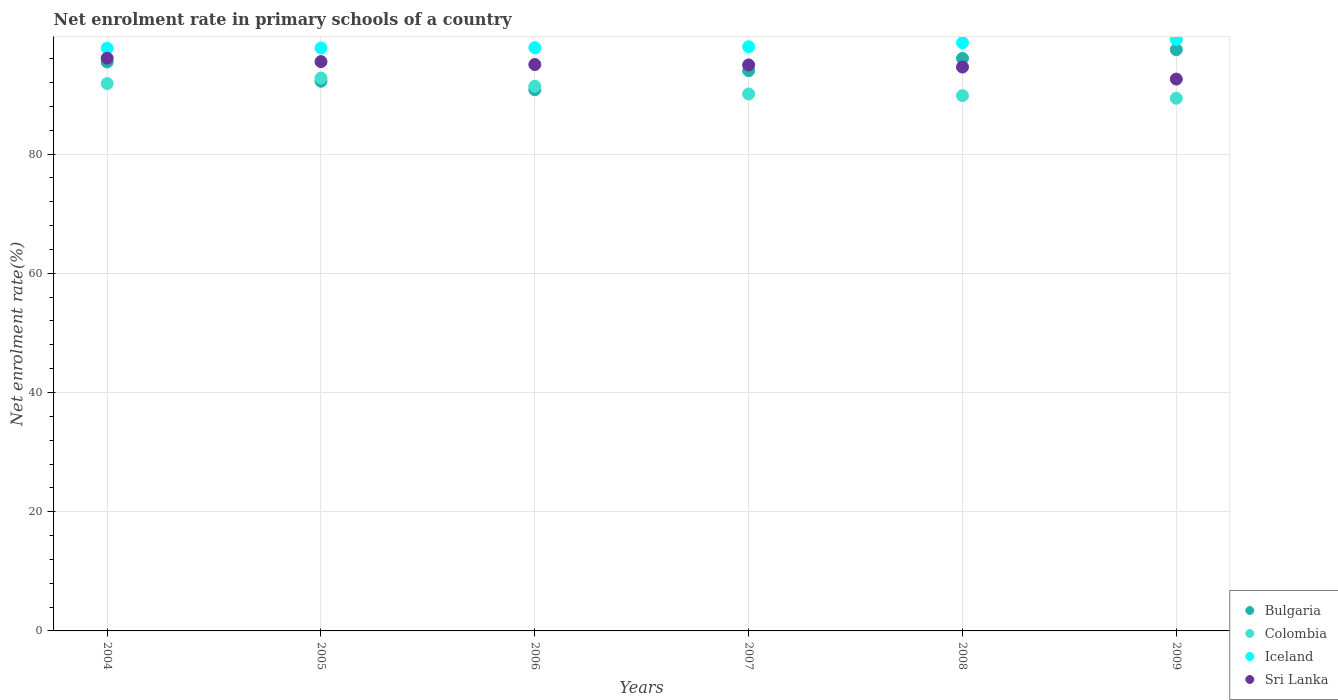How many different coloured dotlines are there?
Provide a short and direct response. 4. What is the net enrolment rate in primary schools in Iceland in 2005?
Give a very brief answer. 97.81. Across all years, what is the maximum net enrolment rate in primary schools in Colombia?
Keep it short and to the point. 92.77. Across all years, what is the minimum net enrolment rate in primary schools in Colombia?
Provide a succinct answer. 89.37. In which year was the net enrolment rate in primary schools in Sri Lanka maximum?
Give a very brief answer. 2004. What is the total net enrolment rate in primary schools in Bulgaria in the graph?
Your response must be concise. 566.08. What is the difference between the net enrolment rate in primary schools in Colombia in 2004 and that in 2007?
Your answer should be very brief. 1.74. What is the difference between the net enrolment rate in primary schools in Colombia in 2004 and the net enrolment rate in primary schools in Bulgaria in 2009?
Your answer should be very brief. -5.69. What is the average net enrolment rate in primary schools in Bulgaria per year?
Make the answer very short. 94.35. In the year 2009, what is the difference between the net enrolment rate in primary schools in Bulgaria and net enrolment rate in primary schools in Iceland?
Offer a terse response. -1.7. What is the ratio of the net enrolment rate in primary schools in Colombia in 2008 to that in 2009?
Your answer should be very brief. 1. Is the difference between the net enrolment rate in primary schools in Bulgaria in 2004 and 2009 greater than the difference between the net enrolment rate in primary schools in Iceland in 2004 and 2009?
Your answer should be compact. No. What is the difference between the highest and the second highest net enrolment rate in primary schools in Sri Lanka?
Ensure brevity in your answer.  0.57. What is the difference between the highest and the lowest net enrolment rate in primary schools in Iceland?
Ensure brevity in your answer.  1.47. Is it the case that in every year, the sum of the net enrolment rate in primary schools in Sri Lanka and net enrolment rate in primary schools in Bulgaria  is greater than the net enrolment rate in primary schools in Iceland?
Offer a terse response. Yes. Is the net enrolment rate in primary schools in Sri Lanka strictly less than the net enrolment rate in primary schools in Bulgaria over the years?
Offer a very short reply. No. How many dotlines are there?
Make the answer very short. 4. What is the difference between two consecutive major ticks on the Y-axis?
Your answer should be compact. 20. Are the values on the major ticks of Y-axis written in scientific E-notation?
Provide a succinct answer. No. Does the graph contain any zero values?
Offer a very short reply. No. Does the graph contain grids?
Provide a short and direct response. Yes. Where does the legend appear in the graph?
Provide a succinct answer. Bottom right. How many legend labels are there?
Your answer should be very brief. 4. What is the title of the graph?
Keep it short and to the point. Net enrolment rate in primary schools of a country. What is the label or title of the X-axis?
Your response must be concise. Years. What is the label or title of the Y-axis?
Give a very brief answer. Net enrolment rate(%). What is the Net enrolment rate(%) in Bulgaria in 2004?
Offer a terse response. 95.46. What is the Net enrolment rate(%) in Colombia in 2004?
Make the answer very short. 91.84. What is the Net enrolment rate(%) of Iceland in 2004?
Offer a terse response. 97.75. What is the Net enrolment rate(%) in Sri Lanka in 2004?
Your answer should be compact. 96.09. What is the Net enrolment rate(%) of Bulgaria in 2005?
Offer a terse response. 92.23. What is the Net enrolment rate(%) of Colombia in 2005?
Offer a very short reply. 92.77. What is the Net enrolment rate(%) of Iceland in 2005?
Provide a short and direct response. 97.81. What is the Net enrolment rate(%) of Sri Lanka in 2005?
Provide a short and direct response. 95.52. What is the Net enrolment rate(%) of Bulgaria in 2006?
Your answer should be very brief. 90.8. What is the Net enrolment rate(%) of Colombia in 2006?
Keep it short and to the point. 91.39. What is the Net enrolment rate(%) of Iceland in 2006?
Make the answer very short. 97.86. What is the Net enrolment rate(%) of Sri Lanka in 2006?
Ensure brevity in your answer.  95.03. What is the Net enrolment rate(%) of Bulgaria in 2007?
Make the answer very short. 94. What is the Net enrolment rate(%) of Colombia in 2007?
Give a very brief answer. 90.09. What is the Net enrolment rate(%) in Iceland in 2007?
Provide a short and direct response. 98.01. What is the Net enrolment rate(%) of Sri Lanka in 2007?
Your answer should be very brief. 94.96. What is the Net enrolment rate(%) in Bulgaria in 2008?
Give a very brief answer. 96.05. What is the Net enrolment rate(%) in Colombia in 2008?
Your response must be concise. 89.81. What is the Net enrolment rate(%) of Iceland in 2008?
Your answer should be very brief. 98.69. What is the Net enrolment rate(%) in Sri Lanka in 2008?
Offer a terse response. 94.61. What is the Net enrolment rate(%) of Bulgaria in 2009?
Give a very brief answer. 97.53. What is the Net enrolment rate(%) of Colombia in 2009?
Provide a short and direct response. 89.37. What is the Net enrolment rate(%) of Iceland in 2009?
Your response must be concise. 99.23. What is the Net enrolment rate(%) in Sri Lanka in 2009?
Provide a short and direct response. 92.59. Across all years, what is the maximum Net enrolment rate(%) in Bulgaria?
Keep it short and to the point. 97.53. Across all years, what is the maximum Net enrolment rate(%) in Colombia?
Ensure brevity in your answer.  92.77. Across all years, what is the maximum Net enrolment rate(%) in Iceland?
Your response must be concise. 99.23. Across all years, what is the maximum Net enrolment rate(%) of Sri Lanka?
Offer a very short reply. 96.09. Across all years, what is the minimum Net enrolment rate(%) of Bulgaria?
Provide a succinct answer. 90.8. Across all years, what is the minimum Net enrolment rate(%) of Colombia?
Make the answer very short. 89.37. Across all years, what is the minimum Net enrolment rate(%) of Iceland?
Ensure brevity in your answer.  97.75. Across all years, what is the minimum Net enrolment rate(%) in Sri Lanka?
Your response must be concise. 92.59. What is the total Net enrolment rate(%) in Bulgaria in the graph?
Provide a short and direct response. 566.08. What is the total Net enrolment rate(%) of Colombia in the graph?
Offer a very short reply. 545.26. What is the total Net enrolment rate(%) of Iceland in the graph?
Provide a short and direct response. 589.35. What is the total Net enrolment rate(%) in Sri Lanka in the graph?
Make the answer very short. 568.8. What is the difference between the Net enrolment rate(%) of Bulgaria in 2004 and that in 2005?
Offer a terse response. 3.23. What is the difference between the Net enrolment rate(%) in Colombia in 2004 and that in 2005?
Your response must be concise. -0.93. What is the difference between the Net enrolment rate(%) of Iceland in 2004 and that in 2005?
Make the answer very short. -0.05. What is the difference between the Net enrolment rate(%) in Sri Lanka in 2004 and that in 2005?
Your response must be concise. 0.57. What is the difference between the Net enrolment rate(%) in Bulgaria in 2004 and that in 2006?
Your answer should be very brief. 4.66. What is the difference between the Net enrolment rate(%) in Colombia in 2004 and that in 2006?
Your answer should be compact. 0.45. What is the difference between the Net enrolment rate(%) of Iceland in 2004 and that in 2006?
Keep it short and to the point. -0.1. What is the difference between the Net enrolment rate(%) in Sri Lanka in 2004 and that in 2006?
Keep it short and to the point. 1.06. What is the difference between the Net enrolment rate(%) in Bulgaria in 2004 and that in 2007?
Offer a very short reply. 1.47. What is the difference between the Net enrolment rate(%) in Colombia in 2004 and that in 2007?
Provide a short and direct response. 1.74. What is the difference between the Net enrolment rate(%) in Iceland in 2004 and that in 2007?
Give a very brief answer. -0.25. What is the difference between the Net enrolment rate(%) in Sri Lanka in 2004 and that in 2007?
Your response must be concise. 1.13. What is the difference between the Net enrolment rate(%) in Bulgaria in 2004 and that in 2008?
Offer a very short reply. -0.59. What is the difference between the Net enrolment rate(%) of Colombia in 2004 and that in 2008?
Make the answer very short. 2.03. What is the difference between the Net enrolment rate(%) of Iceland in 2004 and that in 2008?
Offer a very short reply. -0.94. What is the difference between the Net enrolment rate(%) in Sri Lanka in 2004 and that in 2008?
Keep it short and to the point. 1.48. What is the difference between the Net enrolment rate(%) in Bulgaria in 2004 and that in 2009?
Offer a terse response. -2.06. What is the difference between the Net enrolment rate(%) of Colombia in 2004 and that in 2009?
Provide a short and direct response. 2.47. What is the difference between the Net enrolment rate(%) of Iceland in 2004 and that in 2009?
Provide a succinct answer. -1.47. What is the difference between the Net enrolment rate(%) of Sri Lanka in 2004 and that in 2009?
Offer a very short reply. 3.5. What is the difference between the Net enrolment rate(%) in Bulgaria in 2005 and that in 2006?
Your response must be concise. 1.43. What is the difference between the Net enrolment rate(%) of Colombia in 2005 and that in 2006?
Provide a succinct answer. 1.38. What is the difference between the Net enrolment rate(%) in Iceland in 2005 and that in 2006?
Provide a short and direct response. -0.05. What is the difference between the Net enrolment rate(%) of Sri Lanka in 2005 and that in 2006?
Your answer should be very brief. 0.49. What is the difference between the Net enrolment rate(%) in Bulgaria in 2005 and that in 2007?
Your answer should be compact. -1.77. What is the difference between the Net enrolment rate(%) of Colombia in 2005 and that in 2007?
Ensure brevity in your answer.  2.67. What is the difference between the Net enrolment rate(%) in Iceland in 2005 and that in 2007?
Offer a very short reply. -0.2. What is the difference between the Net enrolment rate(%) of Sri Lanka in 2005 and that in 2007?
Your response must be concise. 0.56. What is the difference between the Net enrolment rate(%) of Bulgaria in 2005 and that in 2008?
Your answer should be very brief. -3.83. What is the difference between the Net enrolment rate(%) in Colombia in 2005 and that in 2008?
Make the answer very short. 2.96. What is the difference between the Net enrolment rate(%) in Iceland in 2005 and that in 2008?
Offer a terse response. -0.89. What is the difference between the Net enrolment rate(%) of Sri Lanka in 2005 and that in 2008?
Provide a short and direct response. 0.91. What is the difference between the Net enrolment rate(%) in Bulgaria in 2005 and that in 2009?
Your answer should be very brief. -5.3. What is the difference between the Net enrolment rate(%) of Colombia in 2005 and that in 2009?
Give a very brief answer. 3.4. What is the difference between the Net enrolment rate(%) in Iceland in 2005 and that in 2009?
Your response must be concise. -1.42. What is the difference between the Net enrolment rate(%) in Sri Lanka in 2005 and that in 2009?
Offer a terse response. 2.93. What is the difference between the Net enrolment rate(%) of Bulgaria in 2006 and that in 2007?
Give a very brief answer. -3.19. What is the difference between the Net enrolment rate(%) of Colombia in 2006 and that in 2007?
Give a very brief answer. 1.29. What is the difference between the Net enrolment rate(%) in Iceland in 2006 and that in 2007?
Give a very brief answer. -0.15. What is the difference between the Net enrolment rate(%) of Sri Lanka in 2006 and that in 2007?
Give a very brief answer. 0.07. What is the difference between the Net enrolment rate(%) in Bulgaria in 2006 and that in 2008?
Your answer should be very brief. -5.25. What is the difference between the Net enrolment rate(%) of Colombia in 2006 and that in 2008?
Your answer should be very brief. 1.58. What is the difference between the Net enrolment rate(%) of Iceland in 2006 and that in 2008?
Your answer should be very brief. -0.84. What is the difference between the Net enrolment rate(%) of Sri Lanka in 2006 and that in 2008?
Make the answer very short. 0.42. What is the difference between the Net enrolment rate(%) in Bulgaria in 2006 and that in 2009?
Offer a very short reply. -6.72. What is the difference between the Net enrolment rate(%) of Colombia in 2006 and that in 2009?
Offer a terse response. 2.02. What is the difference between the Net enrolment rate(%) in Iceland in 2006 and that in 2009?
Give a very brief answer. -1.37. What is the difference between the Net enrolment rate(%) in Sri Lanka in 2006 and that in 2009?
Ensure brevity in your answer.  2.44. What is the difference between the Net enrolment rate(%) of Bulgaria in 2007 and that in 2008?
Ensure brevity in your answer.  -2.06. What is the difference between the Net enrolment rate(%) in Colombia in 2007 and that in 2008?
Offer a very short reply. 0.29. What is the difference between the Net enrolment rate(%) in Iceland in 2007 and that in 2008?
Offer a very short reply. -0.69. What is the difference between the Net enrolment rate(%) of Sri Lanka in 2007 and that in 2008?
Offer a very short reply. 0.35. What is the difference between the Net enrolment rate(%) in Bulgaria in 2007 and that in 2009?
Give a very brief answer. -3.53. What is the difference between the Net enrolment rate(%) in Colombia in 2007 and that in 2009?
Make the answer very short. 0.73. What is the difference between the Net enrolment rate(%) of Iceland in 2007 and that in 2009?
Ensure brevity in your answer.  -1.22. What is the difference between the Net enrolment rate(%) of Sri Lanka in 2007 and that in 2009?
Provide a short and direct response. 2.37. What is the difference between the Net enrolment rate(%) in Bulgaria in 2008 and that in 2009?
Your answer should be very brief. -1.47. What is the difference between the Net enrolment rate(%) in Colombia in 2008 and that in 2009?
Offer a very short reply. 0.44. What is the difference between the Net enrolment rate(%) in Iceland in 2008 and that in 2009?
Provide a short and direct response. -0.53. What is the difference between the Net enrolment rate(%) of Sri Lanka in 2008 and that in 2009?
Make the answer very short. 2.02. What is the difference between the Net enrolment rate(%) of Bulgaria in 2004 and the Net enrolment rate(%) of Colombia in 2005?
Keep it short and to the point. 2.7. What is the difference between the Net enrolment rate(%) of Bulgaria in 2004 and the Net enrolment rate(%) of Iceland in 2005?
Your response must be concise. -2.35. What is the difference between the Net enrolment rate(%) of Bulgaria in 2004 and the Net enrolment rate(%) of Sri Lanka in 2005?
Your answer should be compact. -0.06. What is the difference between the Net enrolment rate(%) of Colombia in 2004 and the Net enrolment rate(%) of Iceland in 2005?
Provide a short and direct response. -5.97. What is the difference between the Net enrolment rate(%) of Colombia in 2004 and the Net enrolment rate(%) of Sri Lanka in 2005?
Your answer should be compact. -3.68. What is the difference between the Net enrolment rate(%) in Iceland in 2004 and the Net enrolment rate(%) in Sri Lanka in 2005?
Your answer should be compact. 2.23. What is the difference between the Net enrolment rate(%) of Bulgaria in 2004 and the Net enrolment rate(%) of Colombia in 2006?
Your answer should be compact. 4.08. What is the difference between the Net enrolment rate(%) of Bulgaria in 2004 and the Net enrolment rate(%) of Iceland in 2006?
Offer a very short reply. -2.39. What is the difference between the Net enrolment rate(%) in Bulgaria in 2004 and the Net enrolment rate(%) in Sri Lanka in 2006?
Your answer should be compact. 0.43. What is the difference between the Net enrolment rate(%) in Colombia in 2004 and the Net enrolment rate(%) in Iceland in 2006?
Provide a succinct answer. -6.02. What is the difference between the Net enrolment rate(%) of Colombia in 2004 and the Net enrolment rate(%) of Sri Lanka in 2006?
Give a very brief answer. -3.19. What is the difference between the Net enrolment rate(%) in Iceland in 2004 and the Net enrolment rate(%) in Sri Lanka in 2006?
Provide a succinct answer. 2.72. What is the difference between the Net enrolment rate(%) in Bulgaria in 2004 and the Net enrolment rate(%) in Colombia in 2007?
Give a very brief answer. 5.37. What is the difference between the Net enrolment rate(%) in Bulgaria in 2004 and the Net enrolment rate(%) in Iceland in 2007?
Your response must be concise. -2.54. What is the difference between the Net enrolment rate(%) in Bulgaria in 2004 and the Net enrolment rate(%) in Sri Lanka in 2007?
Make the answer very short. 0.5. What is the difference between the Net enrolment rate(%) of Colombia in 2004 and the Net enrolment rate(%) of Iceland in 2007?
Your response must be concise. -6.17. What is the difference between the Net enrolment rate(%) of Colombia in 2004 and the Net enrolment rate(%) of Sri Lanka in 2007?
Give a very brief answer. -3.12. What is the difference between the Net enrolment rate(%) of Iceland in 2004 and the Net enrolment rate(%) of Sri Lanka in 2007?
Offer a terse response. 2.79. What is the difference between the Net enrolment rate(%) of Bulgaria in 2004 and the Net enrolment rate(%) of Colombia in 2008?
Ensure brevity in your answer.  5.65. What is the difference between the Net enrolment rate(%) in Bulgaria in 2004 and the Net enrolment rate(%) in Iceland in 2008?
Offer a terse response. -3.23. What is the difference between the Net enrolment rate(%) of Bulgaria in 2004 and the Net enrolment rate(%) of Sri Lanka in 2008?
Keep it short and to the point. 0.85. What is the difference between the Net enrolment rate(%) of Colombia in 2004 and the Net enrolment rate(%) of Iceland in 2008?
Your response must be concise. -6.85. What is the difference between the Net enrolment rate(%) in Colombia in 2004 and the Net enrolment rate(%) in Sri Lanka in 2008?
Your answer should be compact. -2.77. What is the difference between the Net enrolment rate(%) in Iceland in 2004 and the Net enrolment rate(%) in Sri Lanka in 2008?
Offer a terse response. 3.15. What is the difference between the Net enrolment rate(%) in Bulgaria in 2004 and the Net enrolment rate(%) in Colombia in 2009?
Provide a short and direct response. 6.09. What is the difference between the Net enrolment rate(%) in Bulgaria in 2004 and the Net enrolment rate(%) in Iceland in 2009?
Provide a short and direct response. -3.76. What is the difference between the Net enrolment rate(%) in Bulgaria in 2004 and the Net enrolment rate(%) in Sri Lanka in 2009?
Keep it short and to the point. 2.87. What is the difference between the Net enrolment rate(%) in Colombia in 2004 and the Net enrolment rate(%) in Iceland in 2009?
Provide a succinct answer. -7.39. What is the difference between the Net enrolment rate(%) in Colombia in 2004 and the Net enrolment rate(%) in Sri Lanka in 2009?
Your answer should be compact. -0.75. What is the difference between the Net enrolment rate(%) of Iceland in 2004 and the Net enrolment rate(%) of Sri Lanka in 2009?
Offer a terse response. 5.16. What is the difference between the Net enrolment rate(%) of Bulgaria in 2005 and the Net enrolment rate(%) of Colombia in 2006?
Provide a short and direct response. 0.84. What is the difference between the Net enrolment rate(%) in Bulgaria in 2005 and the Net enrolment rate(%) in Iceland in 2006?
Give a very brief answer. -5.63. What is the difference between the Net enrolment rate(%) of Bulgaria in 2005 and the Net enrolment rate(%) of Sri Lanka in 2006?
Provide a succinct answer. -2.8. What is the difference between the Net enrolment rate(%) of Colombia in 2005 and the Net enrolment rate(%) of Iceland in 2006?
Give a very brief answer. -5.09. What is the difference between the Net enrolment rate(%) in Colombia in 2005 and the Net enrolment rate(%) in Sri Lanka in 2006?
Provide a succinct answer. -2.26. What is the difference between the Net enrolment rate(%) of Iceland in 2005 and the Net enrolment rate(%) of Sri Lanka in 2006?
Ensure brevity in your answer.  2.78. What is the difference between the Net enrolment rate(%) of Bulgaria in 2005 and the Net enrolment rate(%) of Colombia in 2007?
Ensure brevity in your answer.  2.13. What is the difference between the Net enrolment rate(%) in Bulgaria in 2005 and the Net enrolment rate(%) in Iceland in 2007?
Your answer should be compact. -5.78. What is the difference between the Net enrolment rate(%) in Bulgaria in 2005 and the Net enrolment rate(%) in Sri Lanka in 2007?
Keep it short and to the point. -2.73. What is the difference between the Net enrolment rate(%) in Colombia in 2005 and the Net enrolment rate(%) in Iceland in 2007?
Your response must be concise. -5.24. What is the difference between the Net enrolment rate(%) of Colombia in 2005 and the Net enrolment rate(%) of Sri Lanka in 2007?
Give a very brief answer. -2.19. What is the difference between the Net enrolment rate(%) of Iceland in 2005 and the Net enrolment rate(%) of Sri Lanka in 2007?
Make the answer very short. 2.85. What is the difference between the Net enrolment rate(%) of Bulgaria in 2005 and the Net enrolment rate(%) of Colombia in 2008?
Your response must be concise. 2.42. What is the difference between the Net enrolment rate(%) of Bulgaria in 2005 and the Net enrolment rate(%) of Iceland in 2008?
Offer a terse response. -6.46. What is the difference between the Net enrolment rate(%) of Bulgaria in 2005 and the Net enrolment rate(%) of Sri Lanka in 2008?
Ensure brevity in your answer.  -2.38. What is the difference between the Net enrolment rate(%) in Colombia in 2005 and the Net enrolment rate(%) in Iceland in 2008?
Give a very brief answer. -5.93. What is the difference between the Net enrolment rate(%) in Colombia in 2005 and the Net enrolment rate(%) in Sri Lanka in 2008?
Offer a very short reply. -1.84. What is the difference between the Net enrolment rate(%) of Iceland in 2005 and the Net enrolment rate(%) of Sri Lanka in 2008?
Your response must be concise. 3.2. What is the difference between the Net enrolment rate(%) of Bulgaria in 2005 and the Net enrolment rate(%) of Colombia in 2009?
Ensure brevity in your answer.  2.86. What is the difference between the Net enrolment rate(%) of Bulgaria in 2005 and the Net enrolment rate(%) of Iceland in 2009?
Your answer should be very brief. -7. What is the difference between the Net enrolment rate(%) in Bulgaria in 2005 and the Net enrolment rate(%) in Sri Lanka in 2009?
Offer a terse response. -0.36. What is the difference between the Net enrolment rate(%) in Colombia in 2005 and the Net enrolment rate(%) in Iceland in 2009?
Your answer should be very brief. -6.46. What is the difference between the Net enrolment rate(%) of Colombia in 2005 and the Net enrolment rate(%) of Sri Lanka in 2009?
Make the answer very short. 0.18. What is the difference between the Net enrolment rate(%) of Iceland in 2005 and the Net enrolment rate(%) of Sri Lanka in 2009?
Ensure brevity in your answer.  5.22. What is the difference between the Net enrolment rate(%) of Bulgaria in 2006 and the Net enrolment rate(%) of Colombia in 2007?
Ensure brevity in your answer.  0.71. What is the difference between the Net enrolment rate(%) in Bulgaria in 2006 and the Net enrolment rate(%) in Iceland in 2007?
Give a very brief answer. -7.2. What is the difference between the Net enrolment rate(%) in Bulgaria in 2006 and the Net enrolment rate(%) in Sri Lanka in 2007?
Provide a succinct answer. -4.16. What is the difference between the Net enrolment rate(%) in Colombia in 2006 and the Net enrolment rate(%) in Iceland in 2007?
Offer a terse response. -6.62. What is the difference between the Net enrolment rate(%) in Colombia in 2006 and the Net enrolment rate(%) in Sri Lanka in 2007?
Give a very brief answer. -3.57. What is the difference between the Net enrolment rate(%) in Iceland in 2006 and the Net enrolment rate(%) in Sri Lanka in 2007?
Provide a succinct answer. 2.9. What is the difference between the Net enrolment rate(%) in Bulgaria in 2006 and the Net enrolment rate(%) in Iceland in 2008?
Keep it short and to the point. -7.89. What is the difference between the Net enrolment rate(%) in Bulgaria in 2006 and the Net enrolment rate(%) in Sri Lanka in 2008?
Your answer should be compact. -3.81. What is the difference between the Net enrolment rate(%) in Colombia in 2006 and the Net enrolment rate(%) in Iceland in 2008?
Give a very brief answer. -7.31. What is the difference between the Net enrolment rate(%) in Colombia in 2006 and the Net enrolment rate(%) in Sri Lanka in 2008?
Provide a succinct answer. -3.22. What is the difference between the Net enrolment rate(%) of Iceland in 2006 and the Net enrolment rate(%) of Sri Lanka in 2008?
Your response must be concise. 3.25. What is the difference between the Net enrolment rate(%) of Bulgaria in 2006 and the Net enrolment rate(%) of Colombia in 2009?
Your answer should be very brief. 1.43. What is the difference between the Net enrolment rate(%) in Bulgaria in 2006 and the Net enrolment rate(%) in Iceland in 2009?
Your answer should be very brief. -8.42. What is the difference between the Net enrolment rate(%) of Bulgaria in 2006 and the Net enrolment rate(%) of Sri Lanka in 2009?
Provide a short and direct response. -1.79. What is the difference between the Net enrolment rate(%) in Colombia in 2006 and the Net enrolment rate(%) in Iceland in 2009?
Make the answer very short. -7.84. What is the difference between the Net enrolment rate(%) in Colombia in 2006 and the Net enrolment rate(%) in Sri Lanka in 2009?
Offer a terse response. -1.2. What is the difference between the Net enrolment rate(%) in Iceland in 2006 and the Net enrolment rate(%) in Sri Lanka in 2009?
Give a very brief answer. 5.27. What is the difference between the Net enrolment rate(%) in Bulgaria in 2007 and the Net enrolment rate(%) in Colombia in 2008?
Make the answer very short. 4.19. What is the difference between the Net enrolment rate(%) in Bulgaria in 2007 and the Net enrolment rate(%) in Iceland in 2008?
Give a very brief answer. -4.7. What is the difference between the Net enrolment rate(%) in Bulgaria in 2007 and the Net enrolment rate(%) in Sri Lanka in 2008?
Give a very brief answer. -0.61. What is the difference between the Net enrolment rate(%) in Colombia in 2007 and the Net enrolment rate(%) in Iceland in 2008?
Ensure brevity in your answer.  -8.6. What is the difference between the Net enrolment rate(%) in Colombia in 2007 and the Net enrolment rate(%) in Sri Lanka in 2008?
Your answer should be very brief. -4.52. What is the difference between the Net enrolment rate(%) in Iceland in 2007 and the Net enrolment rate(%) in Sri Lanka in 2008?
Offer a very short reply. 3.4. What is the difference between the Net enrolment rate(%) in Bulgaria in 2007 and the Net enrolment rate(%) in Colombia in 2009?
Offer a very short reply. 4.63. What is the difference between the Net enrolment rate(%) of Bulgaria in 2007 and the Net enrolment rate(%) of Iceland in 2009?
Offer a very short reply. -5.23. What is the difference between the Net enrolment rate(%) of Bulgaria in 2007 and the Net enrolment rate(%) of Sri Lanka in 2009?
Make the answer very short. 1.41. What is the difference between the Net enrolment rate(%) in Colombia in 2007 and the Net enrolment rate(%) in Iceland in 2009?
Make the answer very short. -9.13. What is the difference between the Net enrolment rate(%) in Colombia in 2007 and the Net enrolment rate(%) in Sri Lanka in 2009?
Your response must be concise. -2.5. What is the difference between the Net enrolment rate(%) of Iceland in 2007 and the Net enrolment rate(%) of Sri Lanka in 2009?
Your response must be concise. 5.42. What is the difference between the Net enrolment rate(%) of Bulgaria in 2008 and the Net enrolment rate(%) of Colombia in 2009?
Make the answer very short. 6.69. What is the difference between the Net enrolment rate(%) of Bulgaria in 2008 and the Net enrolment rate(%) of Iceland in 2009?
Ensure brevity in your answer.  -3.17. What is the difference between the Net enrolment rate(%) of Bulgaria in 2008 and the Net enrolment rate(%) of Sri Lanka in 2009?
Ensure brevity in your answer.  3.46. What is the difference between the Net enrolment rate(%) in Colombia in 2008 and the Net enrolment rate(%) in Iceland in 2009?
Offer a terse response. -9.42. What is the difference between the Net enrolment rate(%) of Colombia in 2008 and the Net enrolment rate(%) of Sri Lanka in 2009?
Give a very brief answer. -2.78. What is the difference between the Net enrolment rate(%) of Iceland in 2008 and the Net enrolment rate(%) of Sri Lanka in 2009?
Your answer should be compact. 6.1. What is the average Net enrolment rate(%) of Bulgaria per year?
Provide a succinct answer. 94.35. What is the average Net enrolment rate(%) in Colombia per year?
Your response must be concise. 90.88. What is the average Net enrolment rate(%) of Iceland per year?
Keep it short and to the point. 98.22. What is the average Net enrolment rate(%) in Sri Lanka per year?
Provide a succinct answer. 94.8. In the year 2004, what is the difference between the Net enrolment rate(%) in Bulgaria and Net enrolment rate(%) in Colombia?
Your answer should be compact. 3.62. In the year 2004, what is the difference between the Net enrolment rate(%) in Bulgaria and Net enrolment rate(%) in Iceland?
Give a very brief answer. -2.29. In the year 2004, what is the difference between the Net enrolment rate(%) of Bulgaria and Net enrolment rate(%) of Sri Lanka?
Your answer should be compact. -0.62. In the year 2004, what is the difference between the Net enrolment rate(%) of Colombia and Net enrolment rate(%) of Iceland?
Your answer should be very brief. -5.92. In the year 2004, what is the difference between the Net enrolment rate(%) in Colombia and Net enrolment rate(%) in Sri Lanka?
Provide a short and direct response. -4.25. In the year 2004, what is the difference between the Net enrolment rate(%) of Iceland and Net enrolment rate(%) of Sri Lanka?
Make the answer very short. 1.67. In the year 2005, what is the difference between the Net enrolment rate(%) of Bulgaria and Net enrolment rate(%) of Colombia?
Your response must be concise. -0.54. In the year 2005, what is the difference between the Net enrolment rate(%) of Bulgaria and Net enrolment rate(%) of Iceland?
Your answer should be very brief. -5.58. In the year 2005, what is the difference between the Net enrolment rate(%) in Bulgaria and Net enrolment rate(%) in Sri Lanka?
Offer a terse response. -3.29. In the year 2005, what is the difference between the Net enrolment rate(%) of Colombia and Net enrolment rate(%) of Iceland?
Provide a short and direct response. -5.04. In the year 2005, what is the difference between the Net enrolment rate(%) in Colombia and Net enrolment rate(%) in Sri Lanka?
Provide a short and direct response. -2.75. In the year 2005, what is the difference between the Net enrolment rate(%) in Iceland and Net enrolment rate(%) in Sri Lanka?
Offer a very short reply. 2.29. In the year 2006, what is the difference between the Net enrolment rate(%) in Bulgaria and Net enrolment rate(%) in Colombia?
Offer a terse response. -0.58. In the year 2006, what is the difference between the Net enrolment rate(%) in Bulgaria and Net enrolment rate(%) in Iceland?
Ensure brevity in your answer.  -7.05. In the year 2006, what is the difference between the Net enrolment rate(%) of Bulgaria and Net enrolment rate(%) of Sri Lanka?
Ensure brevity in your answer.  -4.23. In the year 2006, what is the difference between the Net enrolment rate(%) in Colombia and Net enrolment rate(%) in Iceland?
Your answer should be compact. -6.47. In the year 2006, what is the difference between the Net enrolment rate(%) in Colombia and Net enrolment rate(%) in Sri Lanka?
Offer a very short reply. -3.64. In the year 2006, what is the difference between the Net enrolment rate(%) of Iceland and Net enrolment rate(%) of Sri Lanka?
Keep it short and to the point. 2.83. In the year 2007, what is the difference between the Net enrolment rate(%) of Bulgaria and Net enrolment rate(%) of Colombia?
Give a very brief answer. 3.9. In the year 2007, what is the difference between the Net enrolment rate(%) of Bulgaria and Net enrolment rate(%) of Iceland?
Provide a succinct answer. -4.01. In the year 2007, what is the difference between the Net enrolment rate(%) of Bulgaria and Net enrolment rate(%) of Sri Lanka?
Your answer should be compact. -0.96. In the year 2007, what is the difference between the Net enrolment rate(%) in Colombia and Net enrolment rate(%) in Iceland?
Offer a very short reply. -7.91. In the year 2007, what is the difference between the Net enrolment rate(%) of Colombia and Net enrolment rate(%) of Sri Lanka?
Offer a terse response. -4.87. In the year 2007, what is the difference between the Net enrolment rate(%) in Iceland and Net enrolment rate(%) in Sri Lanka?
Ensure brevity in your answer.  3.05. In the year 2008, what is the difference between the Net enrolment rate(%) of Bulgaria and Net enrolment rate(%) of Colombia?
Offer a terse response. 6.25. In the year 2008, what is the difference between the Net enrolment rate(%) in Bulgaria and Net enrolment rate(%) in Iceland?
Your response must be concise. -2.64. In the year 2008, what is the difference between the Net enrolment rate(%) of Bulgaria and Net enrolment rate(%) of Sri Lanka?
Give a very brief answer. 1.45. In the year 2008, what is the difference between the Net enrolment rate(%) of Colombia and Net enrolment rate(%) of Iceland?
Your answer should be very brief. -8.88. In the year 2008, what is the difference between the Net enrolment rate(%) of Colombia and Net enrolment rate(%) of Sri Lanka?
Your answer should be compact. -4.8. In the year 2008, what is the difference between the Net enrolment rate(%) of Iceland and Net enrolment rate(%) of Sri Lanka?
Make the answer very short. 4.08. In the year 2009, what is the difference between the Net enrolment rate(%) in Bulgaria and Net enrolment rate(%) in Colombia?
Your answer should be very brief. 8.16. In the year 2009, what is the difference between the Net enrolment rate(%) of Bulgaria and Net enrolment rate(%) of Iceland?
Keep it short and to the point. -1.7. In the year 2009, what is the difference between the Net enrolment rate(%) of Bulgaria and Net enrolment rate(%) of Sri Lanka?
Make the answer very short. 4.94. In the year 2009, what is the difference between the Net enrolment rate(%) of Colombia and Net enrolment rate(%) of Iceland?
Offer a terse response. -9.86. In the year 2009, what is the difference between the Net enrolment rate(%) of Colombia and Net enrolment rate(%) of Sri Lanka?
Offer a very short reply. -3.22. In the year 2009, what is the difference between the Net enrolment rate(%) in Iceland and Net enrolment rate(%) in Sri Lanka?
Make the answer very short. 6.64. What is the ratio of the Net enrolment rate(%) in Bulgaria in 2004 to that in 2005?
Give a very brief answer. 1.04. What is the ratio of the Net enrolment rate(%) in Colombia in 2004 to that in 2005?
Provide a succinct answer. 0.99. What is the ratio of the Net enrolment rate(%) in Sri Lanka in 2004 to that in 2005?
Keep it short and to the point. 1.01. What is the ratio of the Net enrolment rate(%) in Bulgaria in 2004 to that in 2006?
Ensure brevity in your answer.  1.05. What is the ratio of the Net enrolment rate(%) in Colombia in 2004 to that in 2006?
Offer a terse response. 1. What is the ratio of the Net enrolment rate(%) in Iceland in 2004 to that in 2006?
Keep it short and to the point. 1. What is the ratio of the Net enrolment rate(%) of Sri Lanka in 2004 to that in 2006?
Offer a terse response. 1.01. What is the ratio of the Net enrolment rate(%) in Bulgaria in 2004 to that in 2007?
Provide a short and direct response. 1.02. What is the ratio of the Net enrolment rate(%) of Colombia in 2004 to that in 2007?
Ensure brevity in your answer.  1.02. What is the ratio of the Net enrolment rate(%) of Sri Lanka in 2004 to that in 2007?
Offer a very short reply. 1.01. What is the ratio of the Net enrolment rate(%) in Bulgaria in 2004 to that in 2008?
Offer a terse response. 0.99. What is the ratio of the Net enrolment rate(%) in Colombia in 2004 to that in 2008?
Your answer should be compact. 1.02. What is the ratio of the Net enrolment rate(%) of Iceland in 2004 to that in 2008?
Your response must be concise. 0.99. What is the ratio of the Net enrolment rate(%) in Sri Lanka in 2004 to that in 2008?
Ensure brevity in your answer.  1.02. What is the ratio of the Net enrolment rate(%) of Bulgaria in 2004 to that in 2009?
Provide a succinct answer. 0.98. What is the ratio of the Net enrolment rate(%) in Colombia in 2004 to that in 2009?
Your answer should be compact. 1.03. What is the ratio of the Net enrolment rate(%) of Iceland in 2004 to that in 2009?
Ensure brevity in your answer.  0.99. What is the ratio of the Net enrolment rate(%) in Sri Lanka in 2004 to that in 2009?
Give a very brief answer. 1.04. What is the ratio of the Net enrolment rate(%) of Bulgaria in 2005 to that in 2006?
Offer a very short reply. 1.02. What is the ratio of the Net enrolment rate(%) in Colombia in 2005 to that in 2006?
Your answer should be compact. 1.02. What is the ratio of the Net enrolment rate(%) of Iceland in 2005 to that in 2006?
Your answer should be very brief. 1. What is the ratio of the Net enrolment rate(%) in Sri Lanka in 2005 to that in 2006?
Keep it short and to the point. 1.01. What is the ratio of the Net enrolment rate(%) of Bulgaria in 2005 to that in 2007?
Offer a very short reply. 0.98. What is the ratio of the Net enrolment rate(%) of Colombia in 2005 to that in 2007?
Provide a short and direct response. 1.03. What is the ratio of the Net enrolment rate(%) of Sri Lanka in 2005 to that in 2007?
Offer a very short reply. 1.01. What is the ratio of the Net enrolment rate(%) of Bulgaria in 2005 to that in 2008?
Give a very brief answer. 0.96. What is the ratio of the Net enrolment rate(%) of Colombia in 2005 to that in 2008?
Make the answer very short. 1.03. What is the ratio of the Net enrolment rate(%) of Sri Lanka in 2005 to that in 2008?
Your response must be concise. 1.01. What is the ratio of the Net enrolment rate(%) of Bulgaria in 2005 to that in 2009?
Offer a terse response. 0.95. What is the ratio of the Net enrolment rate(%) in Colombia in 2005 to that in 2009?
Give a very brief answer. 1.04. What is the ratio of the Net enrolment rate(%) of Iceland in 2005 to that in 2009?
Ensure brevity in your answer.  0.99. What is the ratio of the Net enrolment rate(%) in Sri Lanka in 2005 to that in 2009?
Offer a terse response. 1.03. What is the ratio of the Net enrolment rate(%) in Bulgaria in 2006 to that in 2007?
Offer a terse response. 0.97. What is the ratio of the Net enrolment rate(%) in Colombia in 2006 to that in 2007?
Your answer should be very brief. 1.01. What is the ratio of the Net enrolment rate(%) in Iceland in 2006 to that in 2007?
Offer a terse response. 1. What is the ratio of the Net enrolment rate(%) in Sri Lanka in 2006 to that in 2007?
Provide a short and direct response. 1. What is the ratio of the Net enrolment rate(%) of Bulgaria in 2006 to that in 2008?
Your answer should be compact. 0.95. What is the ratio of the Net enrolment rate(%) of Colombia in 2006 to that in 2008?
Your response must be concise. 1.02. What is the ratio of the Net enrolment rate(%) in Sri Lanka in 2006 to that in 2008?
Provide a short and direct response. 1. What is the ratio of the Net enrolment rate(%) of Colombia in 2006 to that in 2009?
Provide a short and direct response. 1.02. What is the ratio of the Net enrolment rate(%) in Iceland in 2006 to that in 2009?
Your answer should be very brief. 0.99. What is the ratio of the Net enrolment rate(%) in Sri Lanka in 2006 to that in 2009?
Provide a succinct answer. 1.03. What is the ratio of the Net enrolment rate(%) of Bulgaria in 2007 to that in 2008?
Offer a terse response. 0.98. What is the ratio of the Net enrolment rate(%) of Colombia in 2007 to that in 2008?
Provide a succinct answer. 1. What is the ratio of the Net enrolment rate(%) in Iceland in 2007 to that in 2008?
Give a very brief answer. 0.99. What is the ratio of the Net enrolment rate(%) in Bulgaria in 2007 to that in 2009?
Keep it short and to the point. 0.96. What is the ratio of the Net enrolment rate(%) in Iceland in 2007 to that in 2009?
Your answer should be compact. 0.99. What is the ratio of the Net enrolment rate(%) in Sri Lanka in 2007 to that in 2009?
Offer a very short reply. 1.03. What is the ratio of the Net enrolment rate(%) in Bulgaria in 2008 to that in 2009?
Your response must be concise. 0.98. What is the ratio of the Net enrolment rate(%) in Colombia in 2008 to that in 2009?
Your response must be concise. 1. What is the ratio of the Net enrolment rate(%) of Iceland in 2008 to that in 2009?
Your answer should be compact. 0.99. What is the ratio of the Net enrolment rate(%) in Sri Lanka in 2008 to that in 2009?
Give a very brief answer. 1.02. What is the difference between the highest and the second highest Net enrolment rate(%) in Bulgaria?
Your answer should be very brief. 1.47. What is the difference between the highest and the second highest Net enrolment rate(%) of Colombia?
Your answer should be very brief. 0.93. What is the difference between the highest and the second highest Net enrolment rate(%) of Iceland?
Your response must be concise. 0.53. What is the difference between the highest and the second highest Net enrolment rate(%) of Sri Lanka?
Make the answer very short. 0.57. What is the difference between the highest and the lowest Net enrolment rate(%) of Bulgaria?
Your answer should be very brief. 6.72. What is the difference between the highest and the lowest Net enrolment rate(%) in Colombia?
Ensure brevity in your answer.  3.4. What is the difference between the highest and the lowest Net enrolment rate(%) in Iceland?
Give a very brief answer. 1.47. What is the difference between the highest and the lowest Net enrolment rate(%) of Sri Lanka?
Your answer should be very brief. 3.5. 